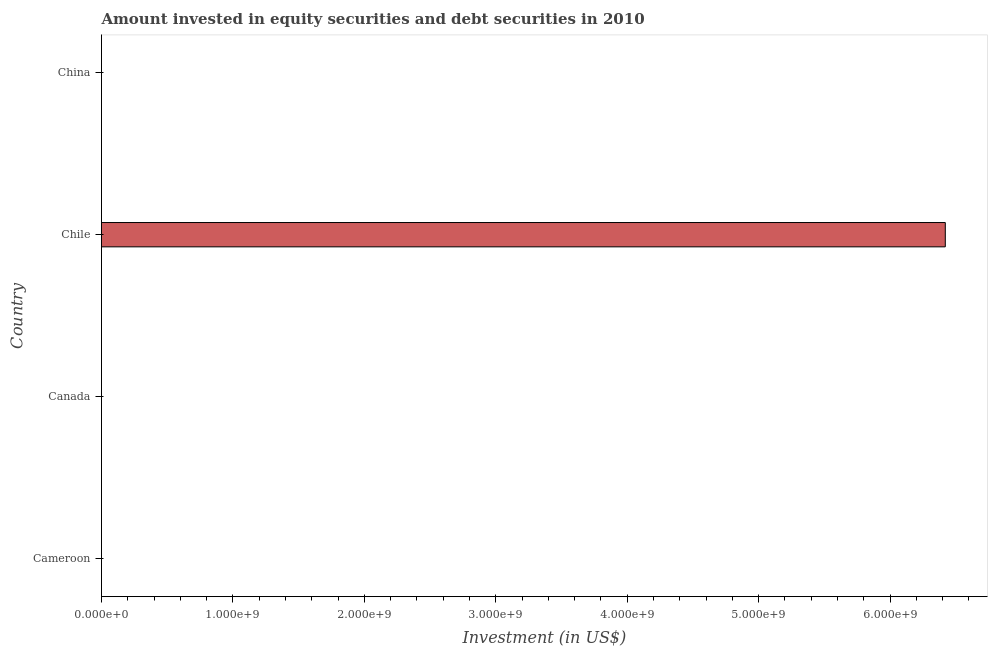Does the graph contain any zero values?
Make the answer very short. Yes. Does the graph contain grids?
Offer a very short reply. No. What is the title of the graph?
Make the answer very short. Amount invested in equity securities and debt securities in 2010. What is the label or title of the X-axis?
Your response must be concise. Investment (in US$). What is the label or title of the Y-axis?
Make the answer very short. Country. Across all countries, what is the maximum portfolio investment?
Keep it short and to the point. 6.42e+09. What is the sum of the portfolio investment?
Provide a short and direct response. 6.42e+09. What is the average portfolio investment per country?
Provide a short and direct response. 1.61e+09. What is the median portfolio investment?
Your response must be concise. 0. In how many countries, is the portfolio investment greater than 3400000000 US$?
Ensure brevity in your answer.  1. What is the difference between the highest and the lowest portfolio investment?
Provide a short and direct response. 6.42e+09. How many bars are there?
Keep it short and to the point. 1. Are the values on the major ticks of X-axis written in scientific E-notation?
Your answer should be compact. Yes. What is the Investment (in US$) of Cameroon?
Keep it short and to the point. 0. What is the Investment (in US$) of Canada?
Give a very brief answer. 0. What is the Investment (in US$) of Chile?
Ensure brevity in your answer.  6.42e+09. What is the Investment (in US$) of China?
Your answer should be very brief. 0. 